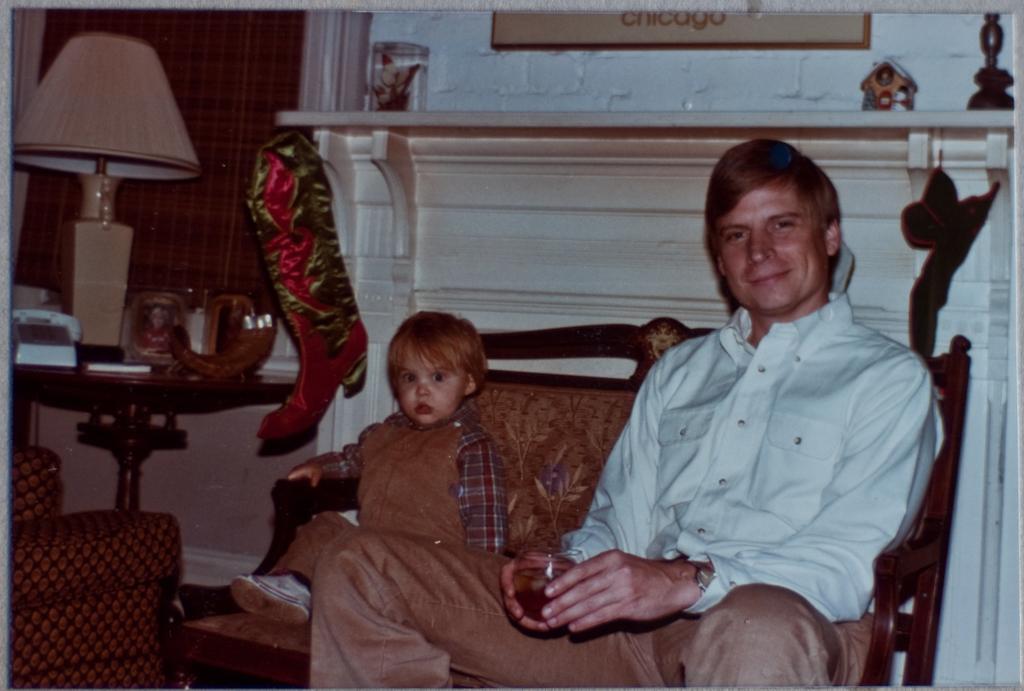How would you summarize this image in a sentence or two? In this image we can see a person and a child sitting on a sofa. In the background of the image there is a wall. To the left side of the image there is a table on which there are objects. 